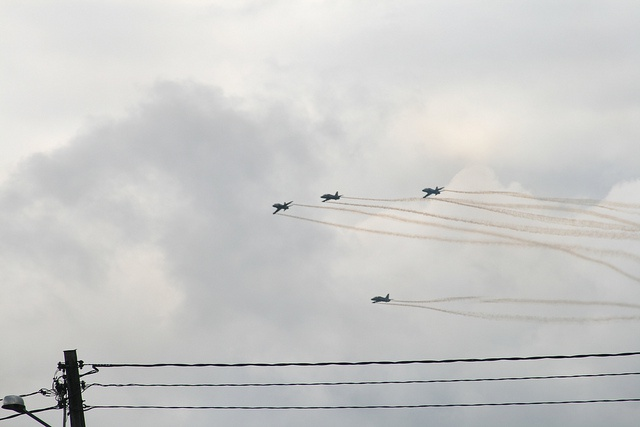Describe the objects in this image and their specific colors. I can see airplane in lightgray, black, gray, darkgray, and purple tones, airplane in lightgray, gray, purple, black, and darkblue tones, airplane in lightgray, black, gray, purple, and darkblue tones, and airplane in lightgray, blue, gray, darkblue, and darkgray tones in this image. 